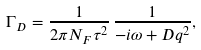<formula> <loc_0><loc_0><loc_500><loc_500>\Gamma _ { D } = \frac { 1 } { 2 \pi N _ { F } \tau ^ { 2 } } \, \frac { 1 } { - i \omega + D q ^ { 2 } } ,</formula> 